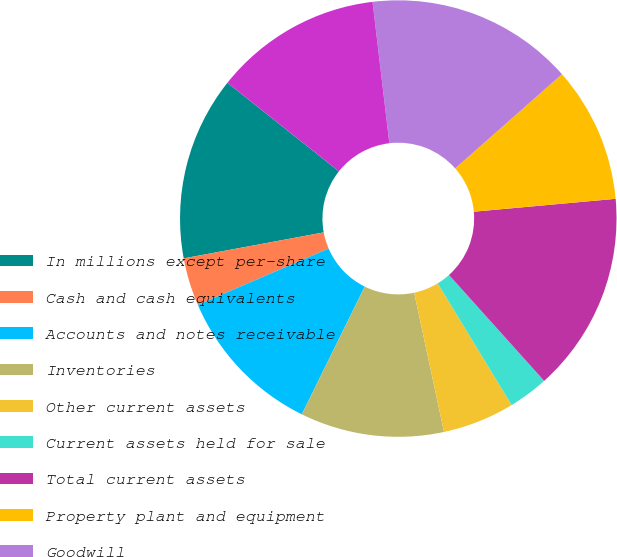<chart> <loc_0><loc_0><loc_500><loc_500><pie_chart><fcel>In millions except per-share<fcel>Cash and cash equivalents<fcel>Accounts and notes receivable<fcel>Inventories<fcel>Other current assets<fcel>Current assets held for sale<fcel>Total current assets<fcel>Property plant and equipment<fcel>Goodwill<fcel>Intangibles net<nl><fcel>13.61%<fcel>3.55%<fcel>11.24%<fcel>10.65%<fcel>5.33%<fcel>2.96%<fcel>14.79%<fcel>10.06%<fcel>15.38%<fcel>12.43%<nl></chart> 